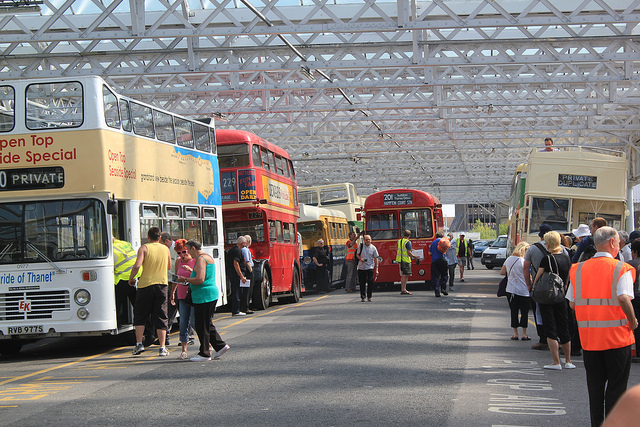Identify and read out the text in this image. Top Special PRIVATE PRIVATE Thanet AND DUPLICATE 0775 RVB EK 01 ride OPEN 229 0 ide pen 